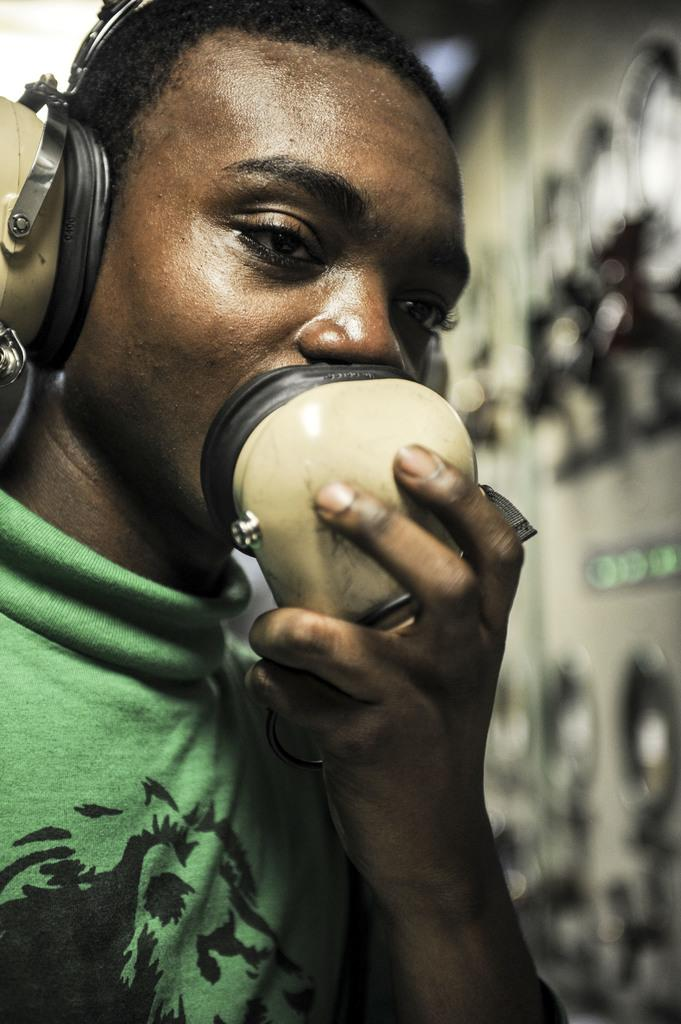What is the main subject of the image? The main subject of the image is a man. What is the man doing in the image? The man is standing and holding an object. Can you describe the man's action with the object? The man is placing the object at his mouth. What is the man wearing in the image? The man is wearing earphones. What type of property can be seen in the background of the image? There is no property visible in the background of the image. What is the man using to look out the window in the image? There is no window present in the image. 